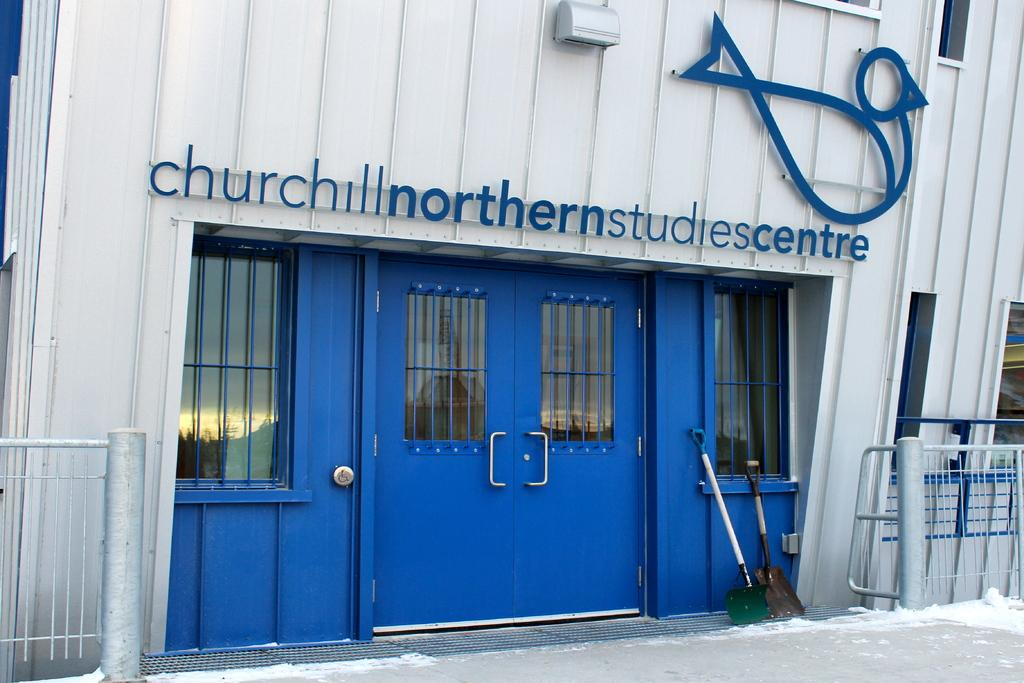<image>
Give a short and clear explanation of the subsequent image. The front of a studio centre that is blue and white. 